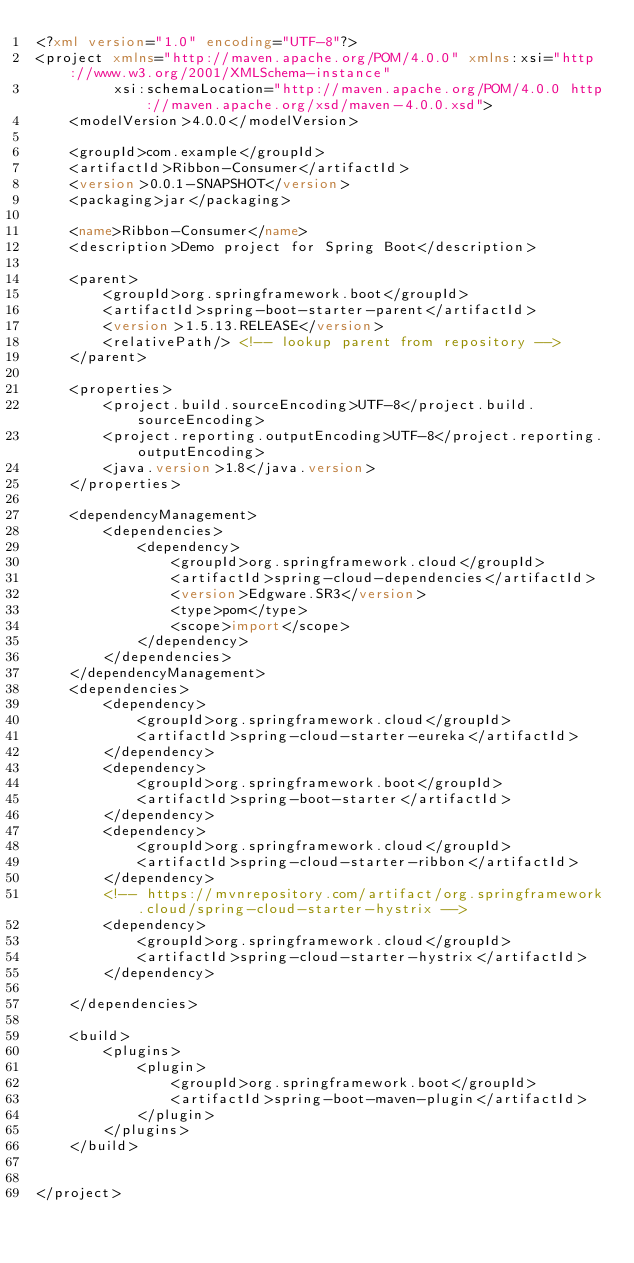Convert code to text. <code><loc_0><loc_0><loc_500><loc_500><_XML_><?xml version="1.0" encoding="UTF-8"?>
<project xmlns="http://maven.apache.org/POM/4.0.0" xmlns:xsi="http://www.w3.org/2001/XMLSchema-instance"
         xsi:schemaLocation="http://maven.apache.org/POM/4.0.0 http://maven.apache.org/xsd/maven-4.0.0.xsd">
    <modelVersion>4.0.0</modelVersion>

    <groupId>com.example</groupId>
    <artifactId>Ribbon-Consumer</artifactId>
    <version>0.0.1-SNAPSHOT</version>
    <packaging>jar</packaging>

    <name>Ribbon-Consumer</name>
    <description>Demo project for Spring Boot</description>

    <parent>
        <groupId>org.springframework.boot</groupId>
        <artifactId>spring-boot-starter-parent</artifactId>
        <version>1.5.13.RELEASE</version>
        <relativePath/> <!-- lookup parent from repository -->
    </parent>

    <properties>
        <project.build.sourceEncoding>UTF-8</project.build.sourceEncoding>
        <project.reporting.outputEncoding>UTF-8</project.reporting.outputEncoding>
        <java.version>1.8</java.version>
    </properties>

    <dependencyManagement>
        <dependencies>
            <dependency>
                <groupId>org.springframework.cloud</groupId>
                <artifactId>spring-cloud-dependencies</artifactId>
                <version>Edgware.SR3</version>
                <type>pom</type>
                <scope>import</scope>
            </dependency>
        </dependencies>
    </dependencyManagement>
    <dependencies>
        <dependency>
            <groupId>org.springframework.cloud</groupId>
            <artifactId>spring-cloud-starter-eureka</artifactId>
        </dependency>
        <dependency>
            <groupId>org.springframework.boot</groupId>
            <artifactId>spring-boot-starter</artifactId>
        </dependency>
        <dependency>
            <groupId>org.springframework.cloud</groupId>
            <artifactId>spring-cloud-starter-ribbon</artifactId>
        </dependency>
        <!-- https://mvnrepository.com/artifact/org.springframework.cloud/spring-cloud-starter-hystrix -->
        <dependency>
            <groupId>org.springframework.cloud</groupId>
            <artifactId>spring-cloud-starter-hystrix</artifactId>
        </dependency>

    </dependencies>

    <build>
        <plugins>
            <plugin>
                <groupId>org.springframework.boot</groupId>
                <artifactId>spring-boot-maven-plugin</artifactId>
            </plugin>
        </plugins>
    </build>


</project>
</code> 